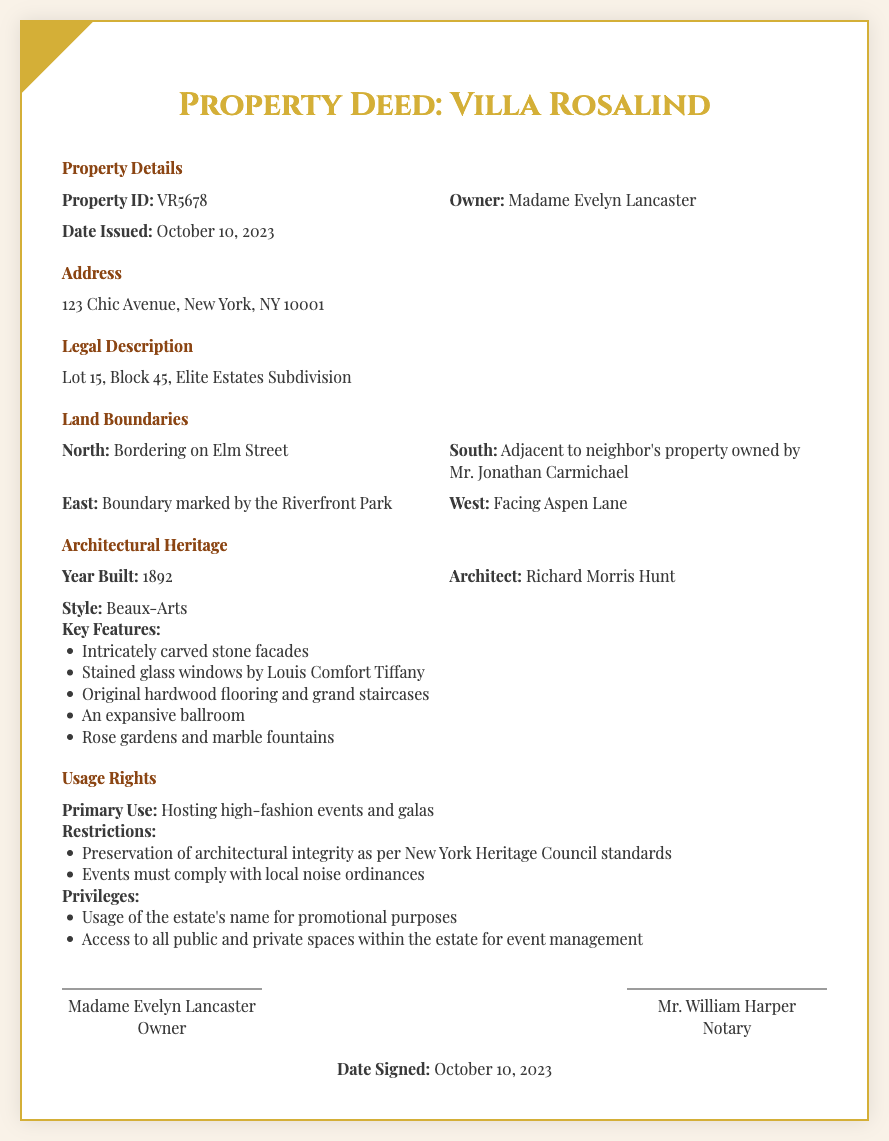What is the Property ID? The Property ID is specified in the Property Details section of the document.
Answer: VR5678 Who is the owner of the property? The owner of the property is mentioned in the Property Details section.
Answer: Madame Evelyn Lancaster What is the address of Villa Rosalind? The address is clearly stated in the Address section of the document.
Answer: 123 Chic Avenue, New York, NY 10001 What year was the property built? The year built is included in the Architectural Heritage section.
Answer: 1892 What architectural style is featured in Villa Rosalind? The architectural style is mentioned in the Architectural Heritage section.
Answer: Beaux-Arts What is the primary use of the estate? The primary use is outlined under the Usage Rights section.
Answer: Hosting high-fashion events and galas Which street borders the property to the North? The northern boundary is specified in the Land Boundaries section.
Answer: Elm Street Who served as the notary for the deed? The notary is listed in the signatures section at the bottom of the document.
Answer: Mr. William Harper What are the key features related to the architectural heritage? Key features can be found in the list provided in the Architectural Heritage section.
Answer: Intricately carved stone facades, Stained glass windows by Louis Comfort Tiffany, Original hardwood flooring and grand staircases, An expansive ballroom, Rose gardens and marble fountains What are the preservation restrictions mentioned? The restrictions are detailed in the Usage Rights section.
Answer: Preservation of architectural integrity as per New York Heritage Council standards, Events must comply with local noise ordinances 